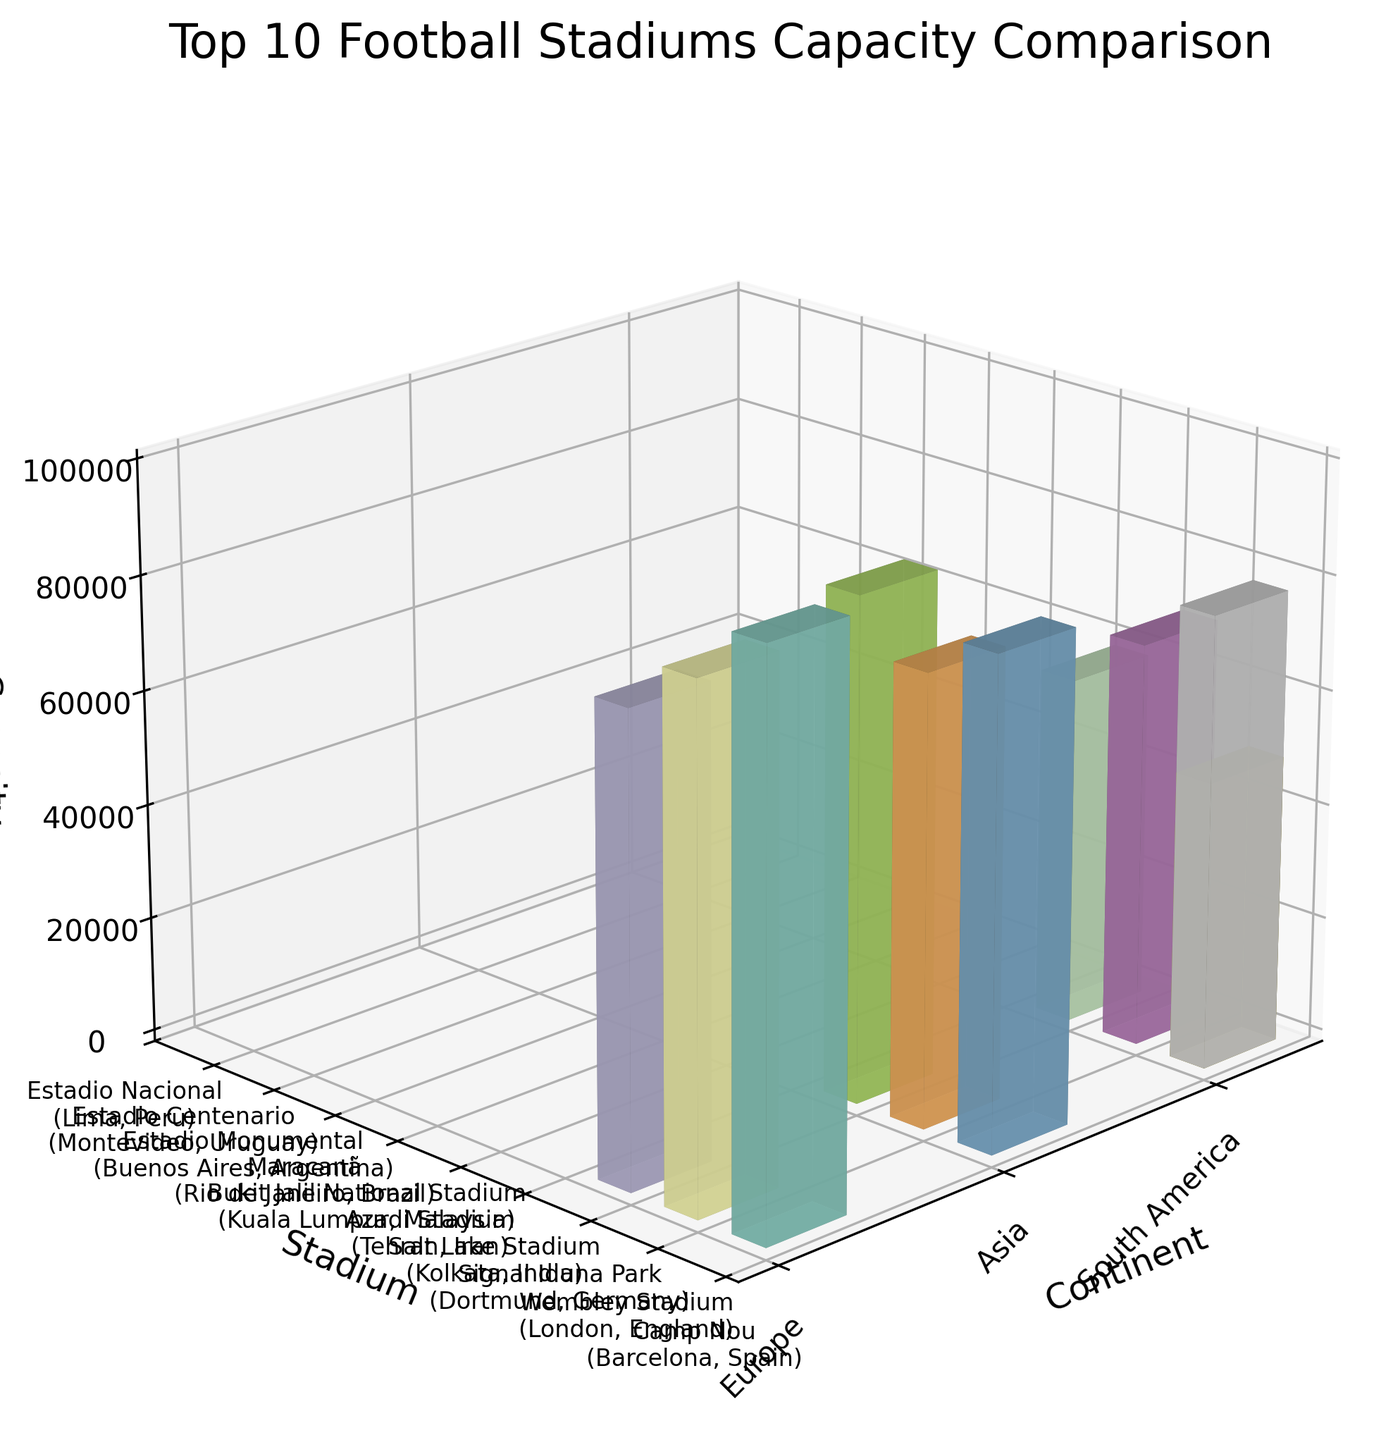Which continent hosts the stadium with the highest capacity? By looking at the 3D bars, identify the tallest one and check the corresponding continent on the x-axis.
Answer: Europe How many stadiums from South America are shown in the figure? Count the number of 3D bars associated with South America on the x-axis.
Answer: 4 What is the capacity of Camp Nou? Locate Camp Nou on the y-axis and check the height of the corresponding 3D bar on the z-axis.
Answer: 99354 Compare the capacity of Wembley Stadium and Maracanã. Which is larger? Locate both Wembley Stadium and Maracanã on the y-axis. Check the heights of the corresponding 3D bars and compare.
Answer: Wembley Stadium What is the average capacity of the stadiums in Asia? Sum the capacities of the stadiums in Asia and divide by the number of stadiums. Calculation: (85000 + 78116 + 87411) / 3 = 83509
Answer: 83509 Which South American stadium has the lowest capacity? Identify the shortest 3D bar under South America on the x-axis and check the corresponding stadium on the y-axis.
Answer: Estadio Nacional Are there more European or Asian stadiums in the figure? Count the number of 3D bars for Europe and Asia on the x-axis.
Answer: Europe What is the difference in capacity between Signal Iduna Park and Estadio Centenario? Locate both Signal Iduna Park and Estadio Centenario on the y-axis. Subtract the capacity of Estadio Centenario from Signal Iduna Park. Calculation: 81365 - 60235 = 21130
Answer: 21130 If the capacities of all the stadiums were combined, what would be the total capacity? Sum the capacities of all the stadiums present. Calculation: 99354 + 90000 + 81365 + 85000 + 78116 + 87411 + 78838 + 70074 + 60235 + 50000 = 780393
Answer: 780393 